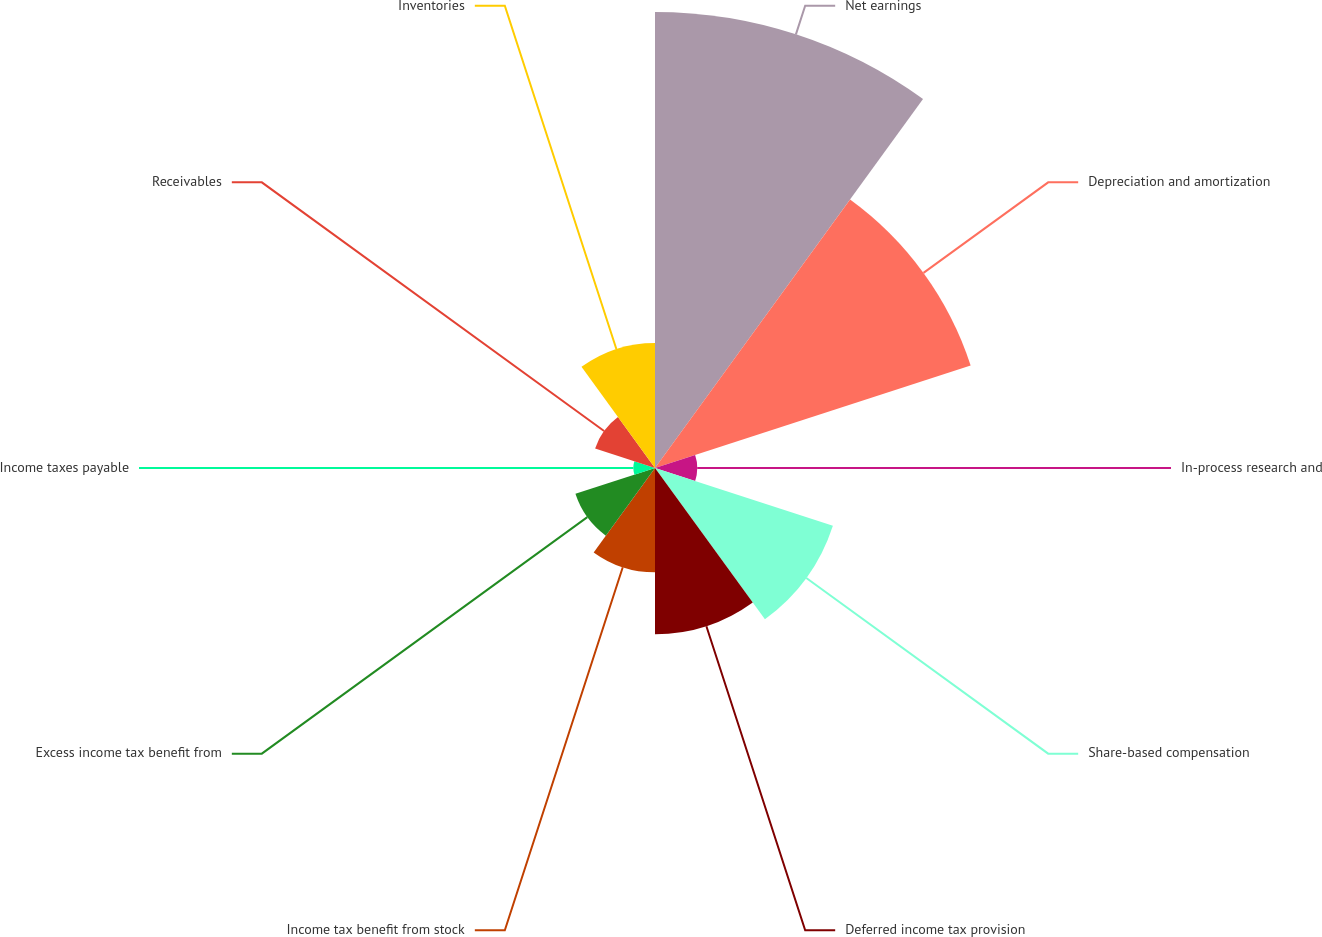Convert chart to OTSL. <chart><loc_0><loc_0><loc_500><loc_500><pie_chart><fcel>Net earnings<fcel>Depreciation and amortization<fcel>In-process research and<fcel>Share-based compensation<fcel>Deferred income tax provision<fcel>Income tax benefit from stock<fcel>Excess income tax benefit from<fcel>Income taxes payable<fcel>Receivables<fcel>Inventories<nl><fcel>28.84%<fcel>20.99%<fcel>2.67%<fcel>11.83%<fcel>10.52%<fcel>6.6%<fcel>5.29%<fcel>1.37%<fcel>3.98%<fcel>7.91%<nl></chart> 